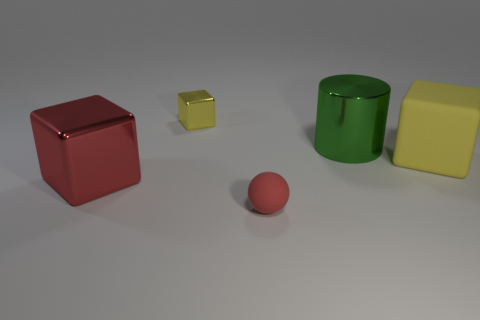How many objects are big matte objects or big shiny objects that are behind the red ball?
Make the answer very short. 3. There is a shiny object that is both in front of the small yellow metal block and left of the small red rubber object; what size is it?
Provide a succinct answer. Large. Are there more metal things that are to the right of the red metal thing than cylinders that are to the right of the big cylinder?
Make the answer very short. Yes. Is the shape of the large yellow rubber object the same as the big metal thing that is to the right of the small red matte object?
Ensure brevity in your answer.  No. What number of other things are there of the same shape as the small rubber thing?
Make the answer very short. 0. What is the color of the metal thing that is both in front of the tiny yellow metallic cube and behind the big yellow rubber object?
Give a very brief answer. Green. The small metal block has what color?
Your answer should be very brief. Yellow. Is the sphere made of the same material as the red thing that is behind the red ball?
Your response must be concise. No. There is a yellow thing that is the same material as the red sphere; what is its shape?
Your answer should be very brief. Cube. The metal cylinder that is the same size as the yellow matte object is what color?
Make the answer very short. Green. 